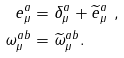Convert formula to latex. <formula><loc_0><loc_0><loc_500><loc_500>e _ { \mu } ^ { a } & = \delta _ { \mu } ^ { a } + \widetilde { e } _ { \mu } ^ { a } \ , \\ \omega _ { \mu } ^ { a b } & = \widetilde { \omega } _ { \mu } ^ { a b } .</formula> 